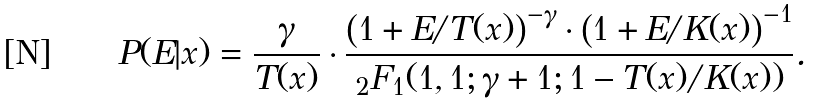<formula> <loc_0><loc_0><loc_500><loc_500>P ( E | x ) = \frac { \gamma } { T ( x ) } \cdot \frac { \left ( 1 + E / T ( x ) \right ) ^ { - \gamma } \cdot \left ( 1 + E / K ( x ) \right ) ^ { - 1 } } { _ { 2 } F _ { 1 } ( 1 , 1 ; \gamma + 1 ; 1 - T ( x ) / K ( x ) ) } .</formula> 